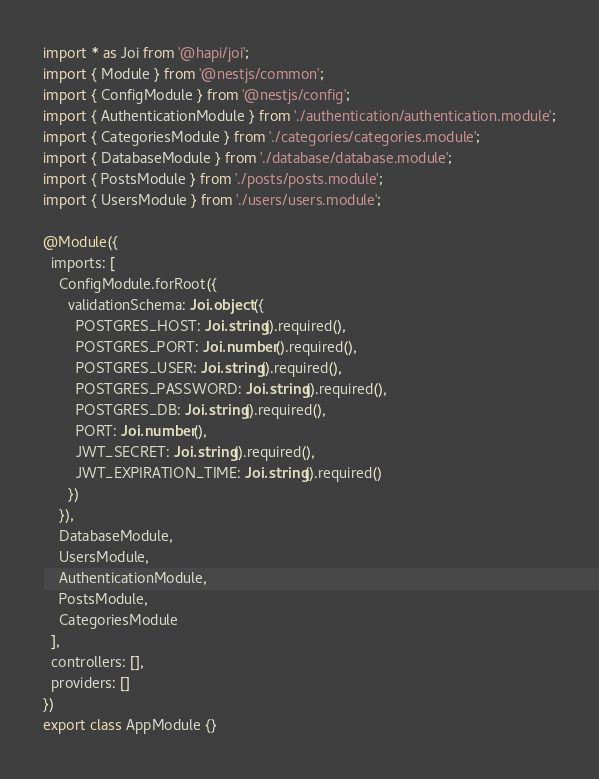<code> <loc_0><loc_0><loc_500><loc_500><_TypeScript_>import * as Joi from '@hapi/joi';
import { Module } from '@nestjs/common';
import { ConfigModule } from '@nestjs/config';
import { AuthenticationModule } from './authentication/authentication.module';
import { CategoriesModule } from './categories/categories.module';
import { DatabaseModule } from './database/database.module';
import { PostsModule } from './posts/posts.module';
import { UsersModule } from './users/users.module';

@Module({
  imports: [
    ConfigModule.forRoot({
      validationSchema: Joi.object({
        POSTGRES_HOST: Joi.string().required(),
        POSTGRES_PORT: Joi.number().required(),
        POSTGRES_USER: Joi.string().required(),
        POSTGRES_PASSWORD: Joi.string().required(),
        POSTGRES_DB: Joi.string().required(),
        PORT: Joi.number(),
        JWT_SECRET: Joi.string().required(),
        JWT_EXPIRATION_TIME: Joi.string().required()
      })
    }),
    DatabaseModule,
    UsersModule,
    AuthenticationModule,
    PostsModule,
    CategoriesModule
  ],
  controllers: [],
  providers: []
})
export class AppModule {}
</code> 